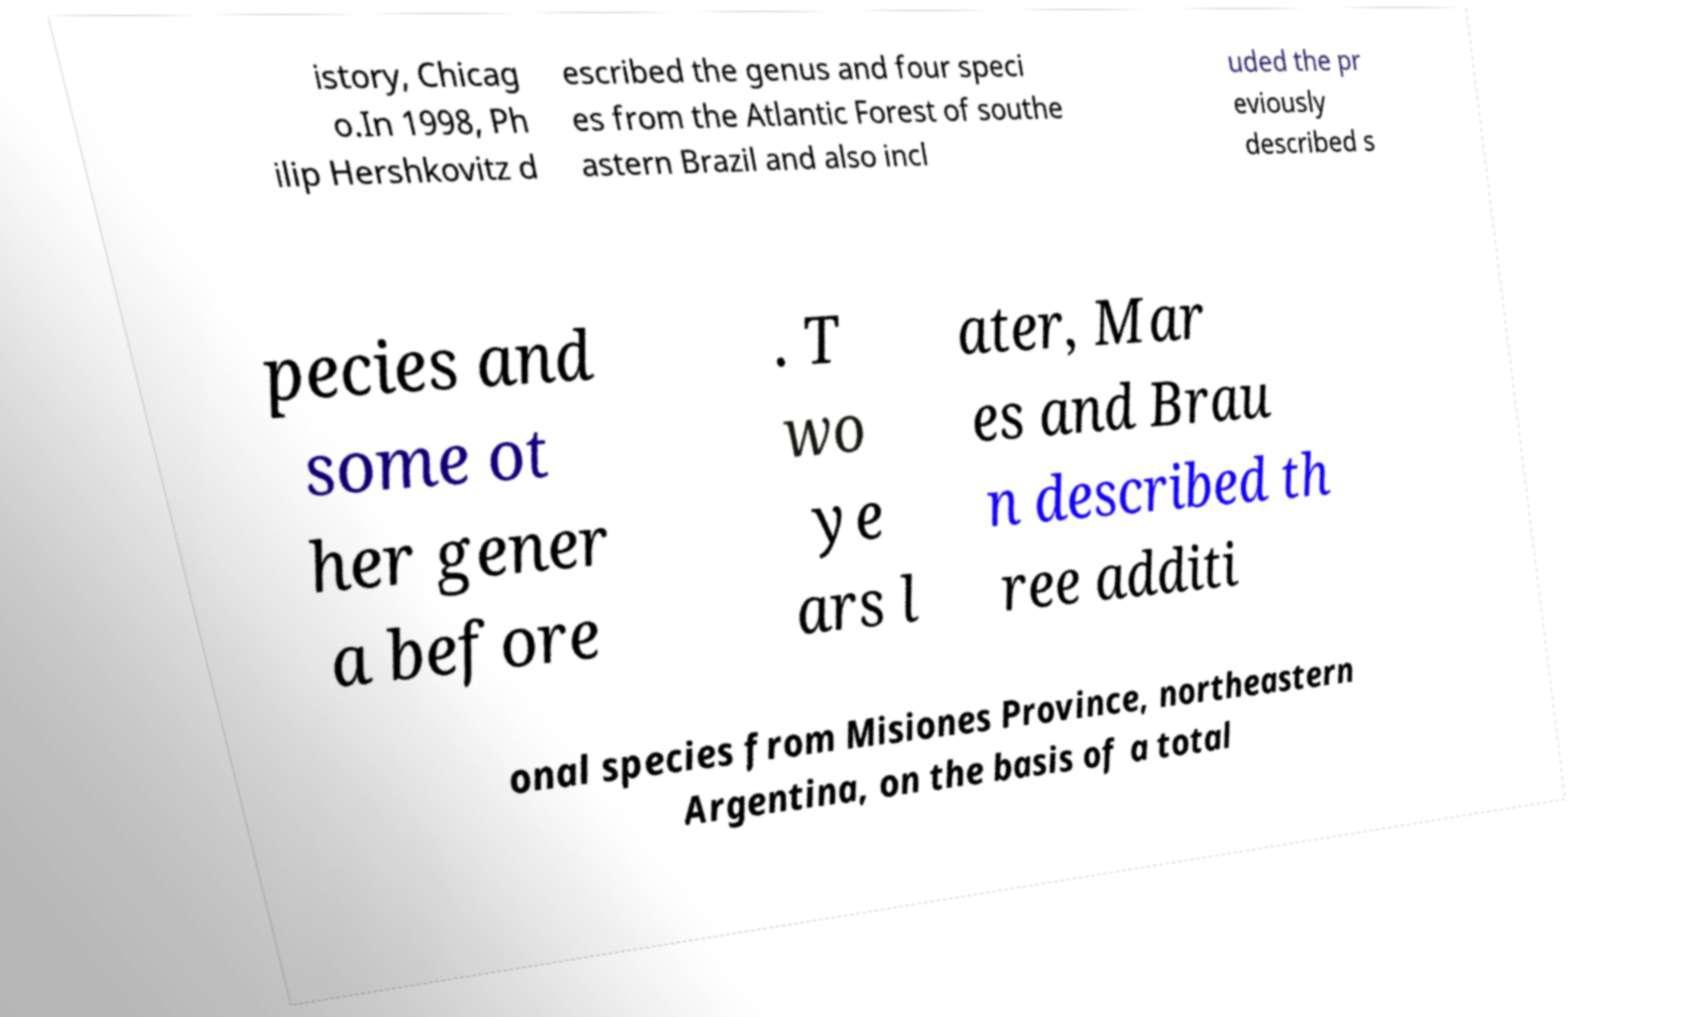I need the written content from this picture converted into text. Can you do that? istory, Chicag o.In 1998, Ph ilip Hershkovitz d escribed the genus and four speci es from the Atlantic Forest of southe astern Brazil and also incl uded the pr eviously described s pecies and some ot her gener a before . T wo ye ars l ater, Mar es and Brau n described th ree additi onal species from Misiones Province, northeastern Argentina, on the basis of a total 